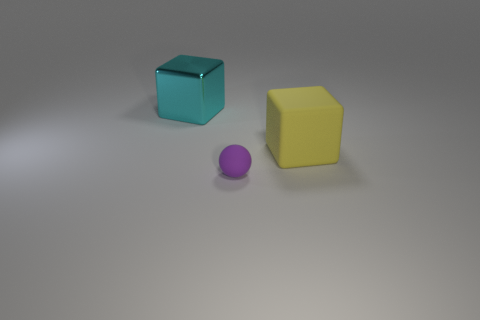Could you tell me what time of day it might be considering the lighting in the scene? The scene doesn't provide specific clues about the time of day since the lighting appears to be artificial, likely from overhead studio lights, creating soft shadows. The lack of natural light indicators, such as sunlight angles or sky visibility, makes it difficult to ascertain the time of day based on this image alone. 